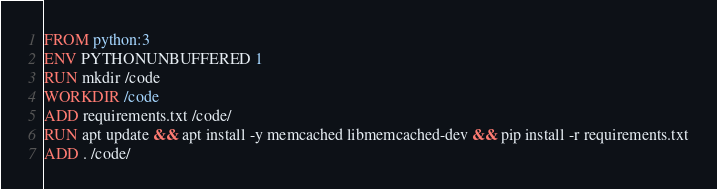<code> <loc_0><loc_0><loc_500><loc_500><_Dockerfile_>FROM python:3
ENV PYTHONUNBUFFERED 1
RUN mkdir /code
WORKDIR /code
ADD requirements.txt /code/
RUN apt update && apt install -y memcached libmemcached-dev && pip install -r requirements.txt
ADD . /code/
</code> 